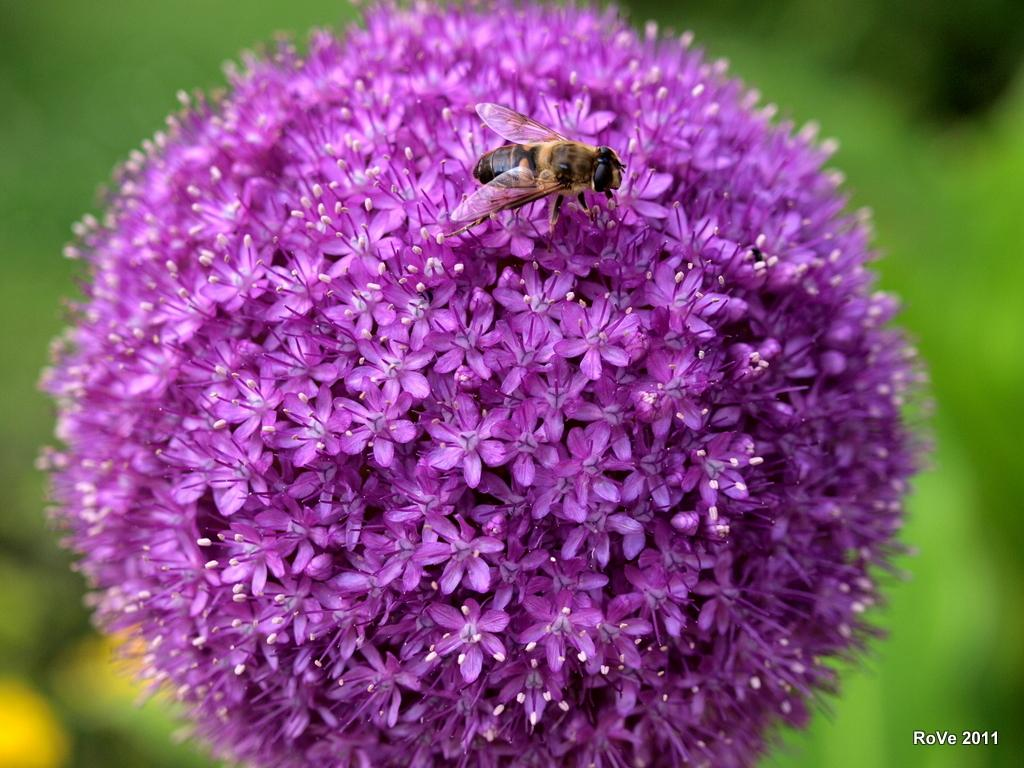What is present in the image? There is a bee in the image. Where is the bee located? The bee is on a flower. What type of play can be seen happening with the fork in the image? There is no fork present in the image, and therefore no play involving a fork can be observed. 